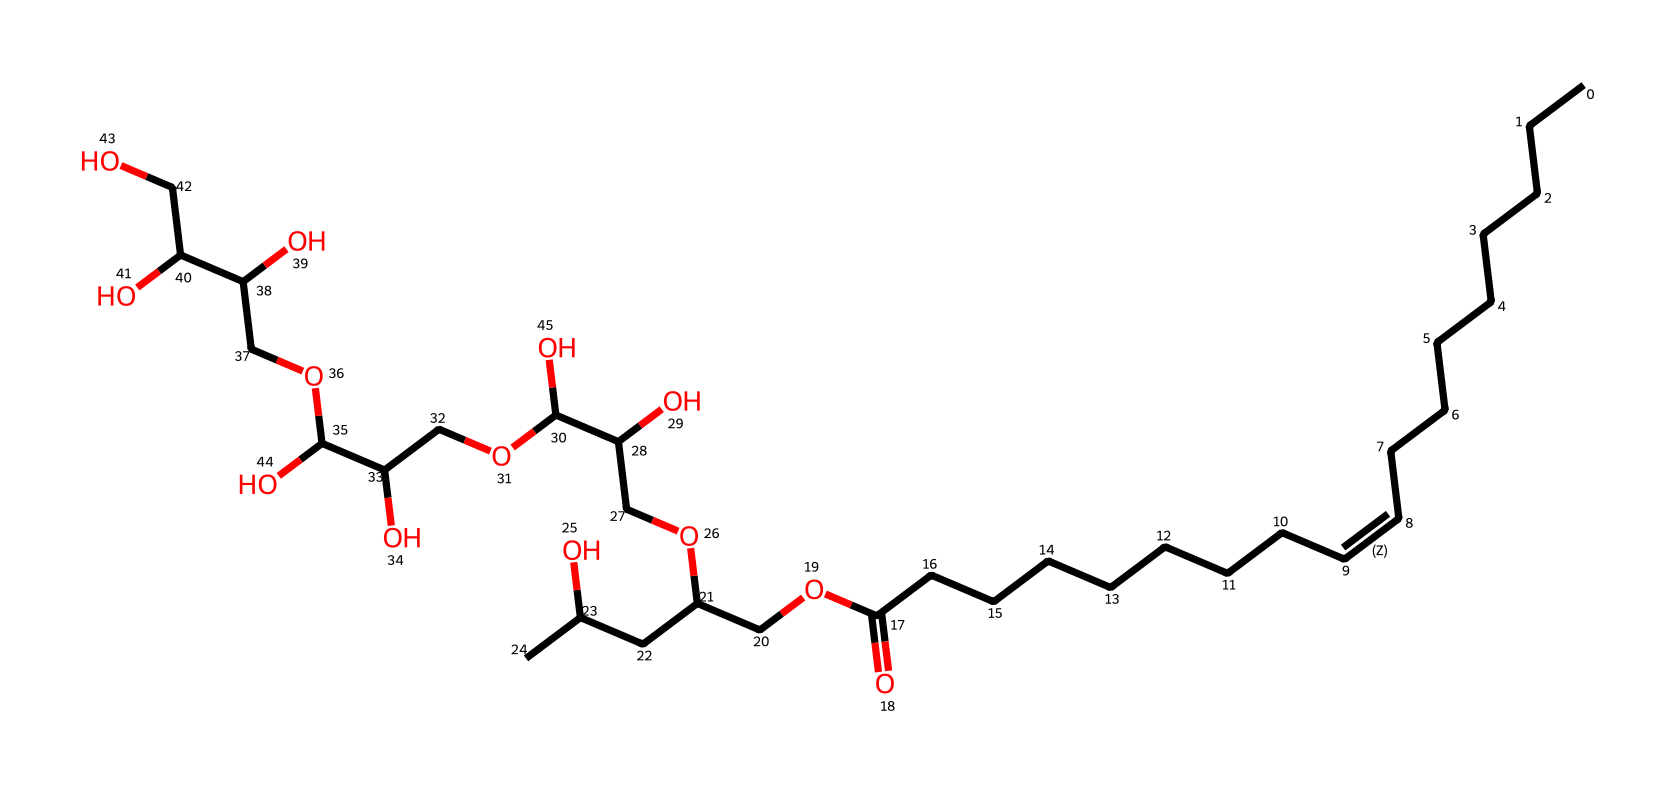What is the molecular formula of polysorbate 80? To determine the molecular formula, we need to count the number of each type of atom present in the SMILES string. The SMILES reveals that there are 20 carbons (C), 38 hydrogens (H), and 6 oxygens (O), giving us the molecular formula C20H38O6.
Answer: C20H38O6 How many oxygen atoms are present in polysorbate 80? By examining the SMILES, we can identify each occurrence of 'O', which represents oxygen atoms. There are 6 occurrences of 'O' in the structural representation.
Answer: 6 What type of functional groups are present in polysorbate 80? Analyzing the structure reveals the presence of a fatty acid (indicative of the carboxylic acid functional group represented by -COOH) and polyol units (characteristic of alcohols represented by -OH groups). Therefore, we recognize carboxylic acid and alcohol functional groups.
Answer: carboxylic acid and alcohol Is polysorbate 80 a hydrophilic or hydrophobic molecule? Polysorbate 80 contains long hydrocarbon chains (which are hydrophobic) and multiple hydroxyl groups (which are hydrophilic). The presence of both types of groups indicates that polysorbate 80 has both hydrophilic and hydrophobic characteristics, but the hydrophilic part is more significant overall, marking it as a surfactant.
Answer: amphiphilic What is the primary role of polysorbate 80 in emulsifying agents? Polysorbate 80's structure facilitates the interaction of oil and water due to its amphiphilic nature. The hydrophobic chains interact with oils, while the hydrophilic head interacts with water, allowing them to mix. This property is crucial for its role in emulsification in food products, especially in in-flight meals.
Answer: emulsifier How does the structure of polysorbate 80 contribute to its surfactant properties? The long hydrophobic fatty acid tail allows polysorbate 80 to interact with oil, while the hydrophilic polyol part provides interaction with water. This dual nature lowers the surface tension between oil and water, promoting the formation of stable emulsions. This mechanism is pivotal in surfactant behavior, highlighting its efficacy in food emulsification.
Answer: lowers surface tension 